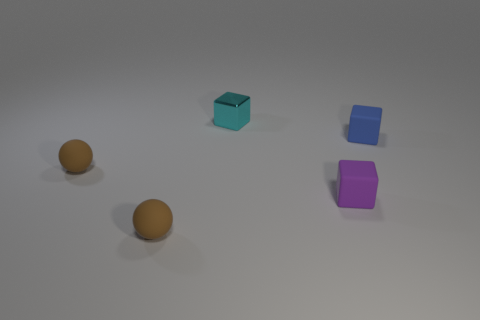What number of balls are either small matte objects or yellow matte things?
Give a very brief answer. 2. What is the color of the tiny block that is the same material as the blue object?
Provide a short and direct response. Purple. Does the blue thing have the same material as the block in front of the blue rubber object?
Make the answer very short. Yes. What number of things are small cyan cylinders or tiny purple blocks?
Offer a terse response. 1. Are there any other things that have the same shape as the small cyan object?
Ensure brevity in your answer.  Yes. There is a shiny thing; how many small blocks are behind it?
Make the answer very short. 0. There is a tiny block behind the block on the right side of the purple cube; what is its material?
Provide a succinct answer. Metal. There is a cyan object that is the same size as the purple matte block; what material is it?
Offer a terse response. Metal. Are there any cyan blocks that have the same size as the purple rubber cube?
Offer a very short reply. Yes. What color is the small block behind the small blue cube?
Offer a terse response. Cyan. 